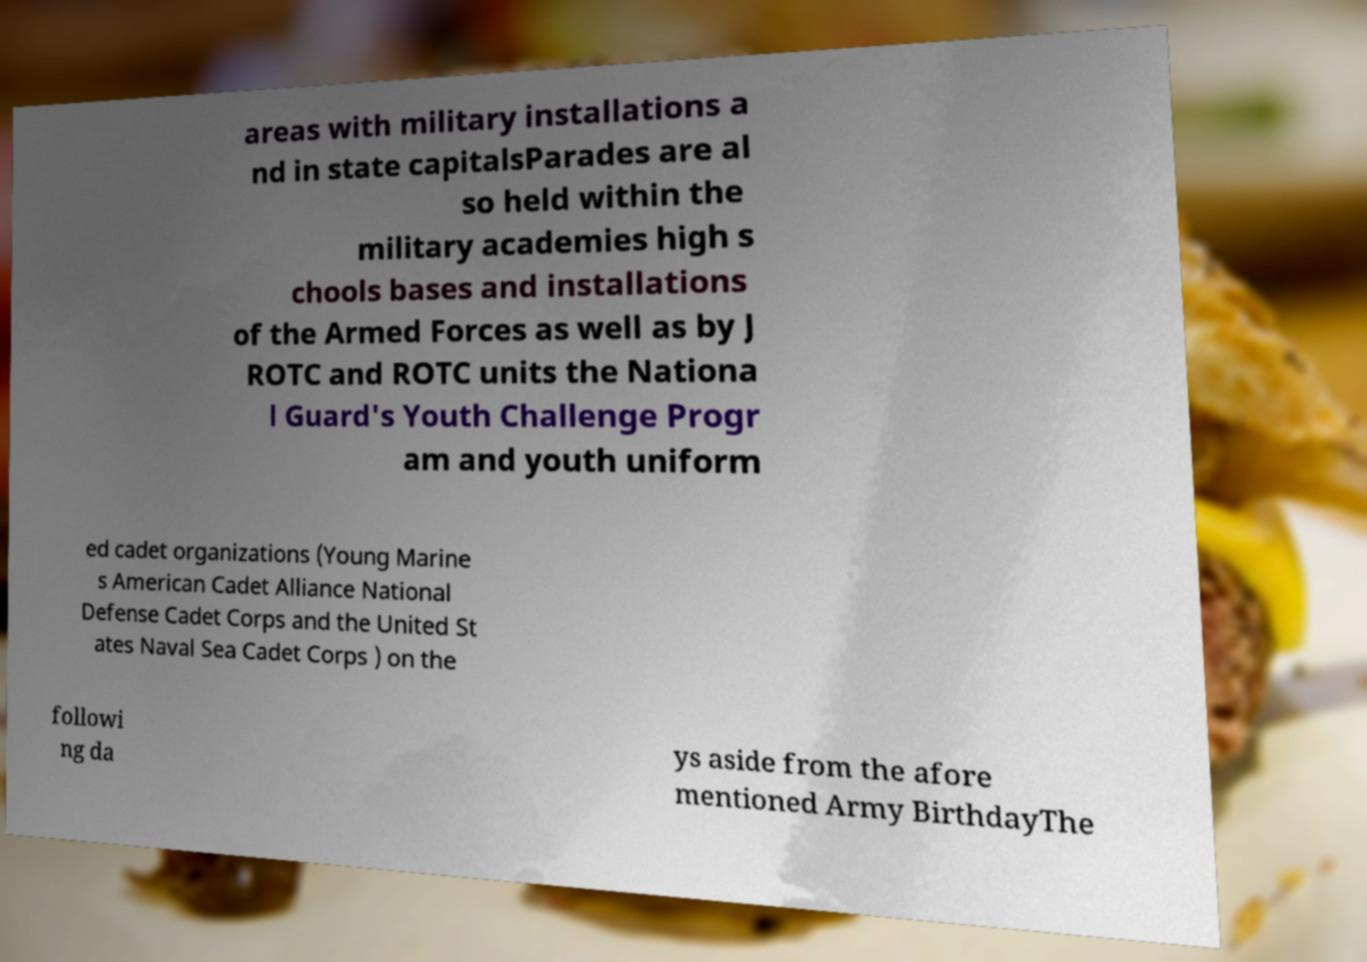I need the written content from this picture converted into text. Can you do that? areas with military installations a nd in state capitalsParades are al so held within the military academies high s chools bases and installations of the Armed Forces as well as by J ROTC and ROTC units the Nationa l Guard's Youth Challenge Progr am and youth uniform ed cadet organizations (Young Marine s American Cadet Alliance National Defense Cadet Corps and the United St ates Naval Sea Cadet Corps ) on the followi ng da ys aside from the afore mentioned Army BirthdayThe 